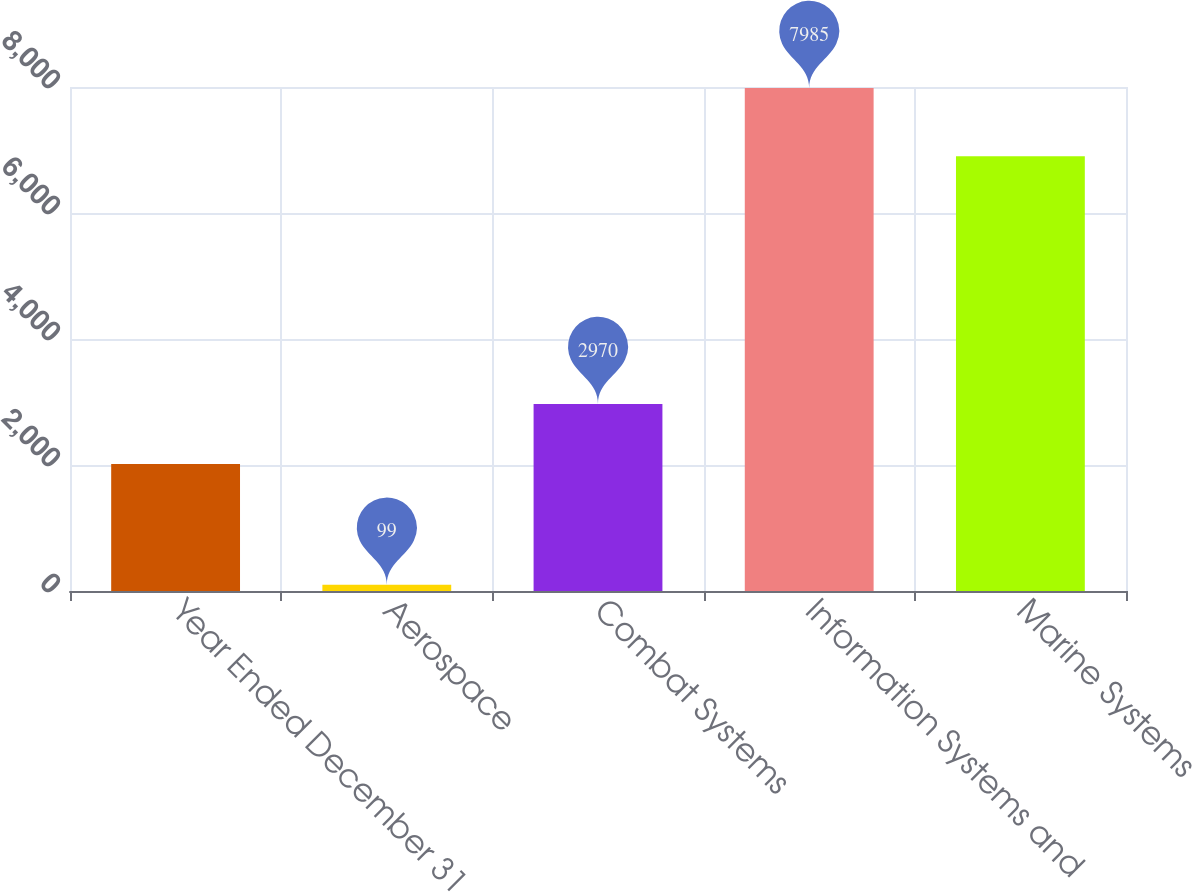Convert chart. <chart><loc_0><loc_0><loc_500><loc_500><bar_chart><fcel>Year Ended December 31<fcel>Aerospace<fcel>Combat Systems<fcel>Information Systems and<fcel>Marine Systems<nl><fcel>2014<fcel>99<fcel>2970<fcel>7985<fcel>6901<nl></chart> 